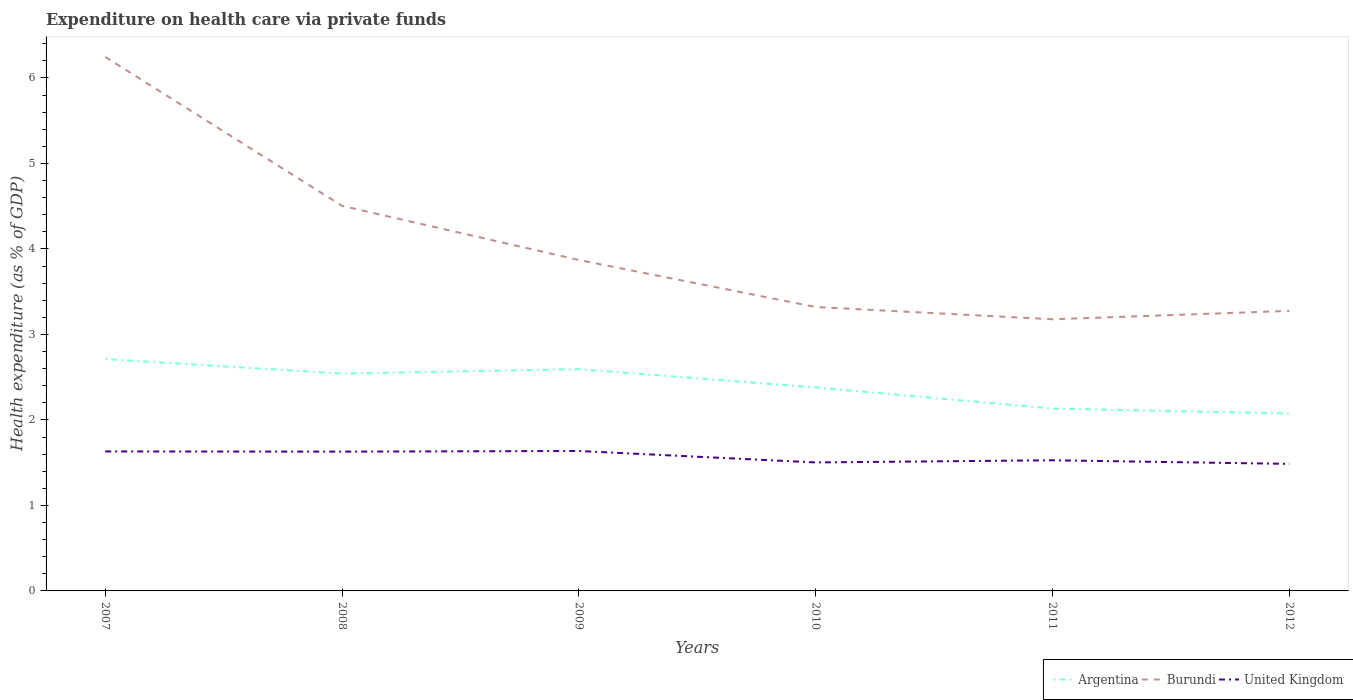How many different coloured lines are there?
Your answer should be very brief. 3. Is the number of lines equal to the number of legend labels?
Offer a terse response. Yes. Across all years, what is the maximum expenditure made on health care in United Kingdom?
Provide a succinct answer. 1.49. What is the total expenditure made on health care in Burundi in the graph?
Keep it short and to the point. 3.07. What is the difference between the highest and the second highest expenditure made on health care in Burundi?
Make the answer very short. 3.07. What is the difference between the highest and the lowest expenditure made on health care in Argentina?
Offer a terse response. 3. Is the expenditure made on health care in United Kingdom strictly greater than the expenditure made on health care in Argentina over the years?
Offer a terse response. Yes. How many lines are there?
Provide a short and direct response. 3. Does the graph contain any zero values?
Ensure brevity in your answer.  No. Does the graph contain grids?
Provide a short and direct response. No. Where does the legend appear in the graph?
Give a very brief answer. Bottom right. How many legend labels are there?
Keep it short and to the point. 3. How are the legend labels stacked?
Offer a very short reply. Horizontal. What is the title of the graph?
Ensure brevity in your answer.  Expenditure on health care via private funds. Does "Tanzania" appear as one of the legend labels in the graph?
Ensure brevity in your answer.  No. What is the label or title of the X-axis?
Give a very brief answer. Years. What is the label or title of the Y-axis?
Make the answer very short. Health expenditure (as % of GDP). What is the Health expenditure (as % of GDP) in Argentina in 2007?
Your answer should be compact. 2.71. What is the Health expenditure (as % of GDP) in Burundi in 2007?
Your answer should be very brief. 6.25. What is the Health expenditure (as % of GDP) of United Kingdom in 2007?
Give a very brief answer. 1.63. What is the Health expenditure (as % of GDP) of Argentina in 2008?
Ensure brevity in your answer.  2.54. What is the Health expenditure (as % of GDP) in Burundi in 2008?
Offer a very short reply. 4.5. What is the Health expenditure (as % of GDP) of United Kingdom in 2008?
Ensure brevity in your answer.  1.63. What is the Health expenditure (as % of GDP) in Argentina in 2009?
Your response must be concise. 2.59. What is the Health expenditure (as % of GDP) in Burundi in 2009?
Keep it short and to the point. 3.87. What is the Health expenditure (as % of GDP) of United Kingdom in 2009?
Provide a short and direct response. 1.64. What is the Health expenditure (as % of GDP) of Argentina in 2010?
Your response must be concise. 2.38. What is the Health expenditure (as % of GDP) of Burundi in 2010?
Your answer should be compact. 3.32. What is the Health expenditure (as % of GDP) in United Kingdom in 2010?
Offer a very short reply. 1.5. What is the Health expenditure (as % of GDP) in Argentina in 2011?
Offer a terse response. 2.13. What is the Health expenditure (as % of GDP) of Burundi in 2011?
Ensure brevity in your answer.  3.18. What is the Health expenditure (as % of GDP) in United Kingdom in 2011?
Offer a terse response. 1.53. What is the Health expenditure (as % of GDP) of Argentina in 2012?
Give a very brief answer. 2.08. What is the Health expenditure (as % of GDP) in Burundi in 2012?
Your answer should be very brief. 3.28. What is the Health expenditure (as % of GDP) in United Kingdom in 2012?
Offer a terse response. 1.49. Across all years, what is the maximum Health expenditure (as % of GDP) in Argentina?
Make the answer very short. 2.71. Across all years, what is the maximum Health expenditure (as % of GDP) of Burundi?
Provide a short and direct response. 6.25. Across all years, what is the maximum Health expenditure (as % of GDP) in United Kingdom?
Ensure brevity in your answer.  1.64. Across all years, what is the minimum Health expenditure (as % of GDP) in Argentina?
Offer a very short reply. 2.08. Across all years, what is the minimum Health expenditure (as % of GDP) in Burundi?
Your answer should be very brief. 3.18. Across all years, what is the minimum Health expenditure (as % of GDP) of United Kingdom?
Provide a short and direct response. 1.49. What is the total Health expenditure (as % of GDP) in Argentina in the graph?
Your answer should be compact. 14.44. What is the total Health expenditure (as % of GDP) of Burundi in the graph?
Make the answer very short. 24.4. What is the total Health expenditure (as % of GDP) of United Kingdom in the graph?
Give a very brief answer. 9.41. What is the difference between the Health expenditure (as % of GDP) of Argentina in 2007 and that in 2008?
Provide a succinct answer. 0.17. What is the difference between the Health expenditure (as % of GDP) in Burundi in 2007 and that in 2008?
Give a very brief answer. 1.74. What is the difference between the Health expenditure (as % of GDP) in United Kingdom in 2007 and that in 2008?
Offer a very short reply. 0. What is the difference between the Health expenditure (as % of GDP) in Argentina in 2007 and that in 2009?
Your answer should be very brief. 0.12. What is the difference between the Health expenditure (as % of GDP) of Burundi in 2007 and that in 2009?
Ensure brevity in your answer.  2.38. What is the difference between the Health expenditure (as % of GDP) of United Kingdom in 2007 and that in 2009?
Your response must be concise. -0.01. What is the difference between the Health expenditure (as % of GDP) in Argentina in 2007 and that in 2010?
Offer a very short reply. 0.33. What is the difference between the Health expenditure (as % of GDP) in Burundi in 2007 and that in 2010?
Make the answer very short. 2.93. What is the difference between the Health expenditure (as % of GDP) in United Kingdom in 2007 and that in 2010?
Make the answer very short. 0.13. What is the difference between the Health expenditure (as % of GDP) in Argentina in 2007 and that in 2011?
Your answer should be compact. 0.58. What is the difference between the Health expenditure (as % of GDP) in Burundi in 2007 and that in 2011?
Your answer should be compact. 3.07. What is the difference between the Health expenditure (as % of GDP) of United Kingdom in 2007 and that in 2011?
Provide a short and direct response. 0.1. What is the difference between the Health expenditure (as % of GDP) in Argentina in 2007 and that in 2012?
Give a very brief answer. 0.64. What is the difference between the Health expenditure (as % of GDP) of Burundi in 2007 and that in 2012?
Your answer should be very brief. 2.97. What is the difference between the Health expenditure (as % of GDP) in United Kingdom in 2007 and that in 2012?
Give a very brief answer. 0.15. What is the difference between the Health expenditure (as % of GDP) of Argentina in 2008 and that in 2009?
Keep it short and to the point. -0.05. What is the difference between the Health expenditure (as % of GDP) in Burundi in 2008 and that in 2009?
Give a very brief answer. 0.63. What is the difference between the Health expenditure (as % of GDP) in United Kingdom in 2008 and that in 2009?
Provide a succinct answer. -0.01. What is the difference between the Health expenditure (as % of GDP) in Argentina in 2008 and that in 2010?
Ensure brevity in your answer.  0.16. What is the difference between the Health expenditure (as % of GDP) of Burundi in 2008 and that in 2010?
Make the answer very short. 1.18. What is the difference between the Health expenditure (as % of GDP) in United Kingdom in 2008 and that in 2010?
Give a very brief answer. 0.13. What is the difference between the Health expenditure (as % of GDP) of Argentina in 2008 and that in 2011?
Your response must be concise. 0.41. What is the difference between the Health expenditure (as % of GDP) in Burundi in 2008 and that in 2011?
Provide a succinct answer. 1.33. What is the difference between the Health expenditure (as % of GDP) of United Kingdom in 2008 and that in 2011?
Your response must be concise. 0.1. What is the difference between the Health expenditure (as % of GDP) in Argentina in 2008 and that in 2012?
Offer a very short reply. 0.47. What is the difference between the Health expenditure (as % of GDP) of Burundi in 2008 and that in 2012?
Provide a short and direct response. 1.23. What is the difference between the Health expenditure (as % of GDP) in United Kingdom in 2008 and that in 2012?
Make the answer very short. 0.14. What is the difference between the Health expenditure (as % of GDP) in Argentina in 2009 and that in 2010?
Give a very brief answer. 0.21. What is the difference between the Health expenditure (as % of GDP) in Burundi in 2009 and that in 2010?
Offer a very short reply. 0.55. What is the difference between the Health expenditure (as % of GDP) of United Kingdom in 2009 and that in 2010?
Give a very brief answer. 0.13. What is the difference between the Health expenditure (as % of GDP) in Argentina in 2009 and that in 2011?
Ensure brevity in your answer.  0.46. What is the difference between the Health expenditure (as % of GDP) in Burundi in 2009 and that in 2011?
Offer a terse response. 0.69. What is the difference between the Health expenditure (as % of GDP) in United Kingdom in 2009 and that in 2011?
Give a very brief answer. 0.11. What is the difference between the Health expenditure (as % of GDP) in Argentina in 2009 and that in 2012?
Make the answer very short. 0.52. What is the difference between the Health expenditure (as % of GDP) of Burundi in 2009 and that in 2012?
Provide a succinct answer. 0.6. What is the difference between the Health expenditure (as % of GDP) of United Kingdom in 2009 and that in 2012?
Give a very brief answer. 0.15. What is the difference between the Health expenditure (as % of GDP) in Argentina in 2010 and that in 2011?
Provide a short and direct response. 0.25. What is the difference between the Health expenditure (as % of GDP) in Burundi in 2010 and that in 2011?
Provide a short and direct response. 0.14. What is the difference between the Health expenditure (as % of GDP) of United Kingdom in 2010 and that in 2011?
Your answer should be compact. -0.03. What is the difference between the Health expenditure (as % of GDP) of Argentina in 2010 and that in 2012?
Provide a short and direct response. 0.31. What is the difference between the Health expenditure (as % of GDP) in Burundi in 2010 and that in 2012?
Your answer should be compact. 0.05. What is the difference between the Health expenditure (as % of GDP) of United Kingdom in 2010 and that in 2012?
Make the answer very short. 0.02. What is the difference between the Health expenditure (as % of GDP) of Argentina in 2011 and that in 2012?
Provide a short and direct response. 0.06. What is the difference between the Health expenditure (as % of GDP) of Burundi in 2011 and that in 2012?
Your response must be concise. -0.1. What is the difference between the Health expenditure (as % of GDP) in United Kingdom in 2011 and that in 2012?
Keep it short and to the point. 0.04. What is the difference between the Health expenditure (as % of GDP) in Argentina in 2007 and the Health expenditure (as % of GDP) in Burundi in 2008?
Your answer should be very brief. -1.79. What is the difference between the Health expenditure (as % of GDP) of Argentina in 2007 and the Health expenditure (as % of GDP) of United Kingdom in 2008?
Ensure brevity in your answer.  1.08. What is the difference between the Health expenditure (as % of GDP) of Burundi in 2007 and the Health expenditure (as % of GDP) of United Kingdom in 2008?
Your response must be concise. 4.62. What is the difference between the Health expenditure (as % of GDP) in Argentina in 2007 and the Health expenditure (as % of GDP) in Burundi in 2009?
Provide a short and direct response. -1.16. What is the difference between the Health expenditure (as % of GDP) in Argentina in 2007 and the Health expenditure (as % of GDP) in United Kingdom in 2009?
Your response must be concise. 1.07. What is the difference between the Health expenditure (as % of GDP) in Burundi in 2007 and the Health expenditure (as % of GDP) in United Kingdom in 2009?
Your answer should be very brief. 4.61. What is the difference between the Health expenditure (as % of GDP) of Argentina in 2007 and the Health expenditure (as % of GDP) of Burundi in 2010?
Make the answer very short. -0.61. What is the difference between the Health expenditure (as % of GDP) in Argentina in 2007 and the Health expenditure (as % of GDP) in United Kingdom in 2010?
Provide a short and direct response. 1.21. What is the difference between the Health expenditure (as % of GDP) in Burundi in 2007 and the Health expenditure (as % of GDP) in United Kingdom in 2010?
Make the answer very short. 4.74. What is the difference between the Health expenditure (as % of GDP) of Argentina in 2007 and the Health expenditure (as % of GDP) of Burundi in 2011?
Provide a succinct answer. -0.47. What is the difference between the Health expenditure (as % of GDP) of Argentina in 2007 and the Health expenditure (as % of GDP) of United Kingdom in 2011?
Your answer should be compact. 1.18. What is the difference between the Health expenditure (as % of GDP) of Burundi in 2007 and the Health expenditure (as % of GDP) of United Kingdom in 2011?
Provide a succinct answer. 4.72. What is the difference between the Health expenditure (as % of GDP) of Argentina in 2007 and the Health expenditure (as % of GDP) of Burundi in 2012?
Your answer should be very brief. -0.56. What is the difference between the Health expenditure (as % of GDP) of Argentina in 2007 and the Health expenditure (as % of GDP) of United Kingdom in 2012?
Ensure brevity in your answer.  1.23. What is the difference between the Health expenditure (as % of GDP) of Burundi in 2007 and the Health expenditure (as % of GDP) of United Kingdom in 2012?
Your answer should be very brief. 4.76. What is the difference between the Health expenditure (as % of GDP) of Argentina in 2008 and the Health expenditure (as % of GDP) of Burundi in 2009?
Provide a short and direct response. -1.33. What is the difference between the Health expenditure (as % of GDP) of Argentina in 2008 and the Health expenditure (as % of GDP) of United Kingdom in 2009?
Make the answer very short. 0.91. What is the difference between the Health expenditure (as % of GDP) in Burundi in 2008 and the Health expenditure (as % of GDP) in United Kingdom in 2009?
Offer a terse response. 2.87. What is the difference between the Health expenditure (as % of GDP) of Argentina in 2008 and the Health expenditure (as % of GDP) of Burundi in 2010?
Your response must be concise. -0.78. What is the difference between the Health expenditure (as % of GDP) in Argentina in 2008 and the Health expenditure (as % of GDP) in United Kingdom in 2010?
Provide a short and direct response. 1.04. What is the difference between the Health expenditure (as % of GDP) of Burundi in 2008 and the Health expenditure (as % of GDP) of United Kingdom in 2010?
Provide a succinct answer. 3. What is the difference between the Health expenditure (as % of GDP) in Argentina in 2008 and the Health expenditure (as % of GDP) in Burundi in 2011?
Provide a succinct answer. -0.63. What is the difference between the Health expenditure (as % of GDP) in Argentina in 2008 and the Health expenditure (as % of GDP) in United Kingdom in 2011?
Your answer should be compact. 1.01. What is the difference between the Health expenditure (as % of GDP) of Burundi in 2008 and the Health expenditure (as % of GDP) of United Kingdom in 2011?
Ensure brevity in your answer.  2.98. What is the difference between the Health expenditure (as % of GDP) in Argentina in 2008 and the Health expenditure (as % of GDP) in Burundi in 2012?
Ensure brevity in your answer.  -0.73. What is the difference between the Health expenditure (as % of GDP) in Argentina in 2008 and the Health expenditure (as % of GDP) in United Kingdom in 2012?
Give a very brief answer. 1.06. What is the difference between the Health expenditure (as % of GDP) of Burundi in 2008 and the Health expenditure (as % of GDP) of United Kingdom in 2012?
Your answer should be compact. 3.02. What is the difference between the Health expenditure (as % of GDP) of Argentina in 2009 and the Health expenditure (as % of GDP) of Burundi in 2010?
Ensure brevity in your answer.  -0.73. What is the difference between the Health expenditure (as % of GDP) in Argentina in 2009 and the Health expenditure (as % of GDP) in United Kingdom in 2010?
Provide a succinct answer. 1.09. What is the difference between the Health expenditure (as % of GDP) of Burundi in 2009 and the Health expenditure (as % of GDP) of United Kingdom in 2010?
Your answer should be compact. 2.37. What is the difference between the Health expenditure (as % of GDP) in Argentina in 2009 and the Health expenditure (as % of GDP) in Burundi in 2011?
Keep it short and to the point. -0.58. What is the difference between the Health expenditure (as % of GDP) in Argentina in 2009 and the Health expenditure (as % of GDP) in United Kingdom in 2011?
Offer a terse response. 1.07. What is the difference between the Health expenditure (as % of GDP) of Burundi in 2009 and the Health expenditure (as % of GDP) of United Kingdom in 2011?
Ensure brevity in your answer.  2.34. What is the difference between the Health expenditure (as % of GDP) in Argentina in 2009 and the Health expenditure (as % of GDP) in Burundi in 2012?
Ensure brevity in your answer.  -0.68. What is the difference between the Health expenditure (as % of GDP) in Argentina in 2009 and the Health expenditure (as % of GDP) in United Kingdom in 2012?
Offer a very short reply. 1.11. What is the difference between the Health expenditure (as % of GDP) of Burundi in 2009 and the Health expenditure (as % of GDP) of United Kingdom in 2012?
Ensure brevity in your answer.  2.39. What is the difference between the Health expenditure (as % of GDP) in Argentina in 2010 and the Health expenditure (as % of GDP) in Burundi in 2011?
Your answer should be compact. -0.8. What is the difference between the Health expenditure (as % of GDP) of Argentina in 2010 and the Health expenditure (as % of GDP) of United Kingdom in 2011?
Your answer should be compact. 0.85. What is the difference between the Health expenditure (as % of GDP) in Burundi in 2010 and the Health expenditure (as % of GDP) in United Kingdom in 2011?
Provide a short and direct response. 1.79. What is the difference between the Health expenditure (as % of GDP) of Argentina in 2010 and the Health expenditure (as % of GDP) of Burundi in 2012?
Give a very brief answer. -0.9. What is the difference between the Health expenditure (as % of GDP) of Argentina in 2010 and the Health expenditure (as % of GDP) of United Kingdom in 2012?
Your answer should be very brief. 0.89. What is the difference between the Health expenditure (as % of GDP) in Burundi in 2010 and the Health expenditure (as % of GDP) in United Kingdom in 2012?
Keep it short and to the point. 1.83. What is the difference between the Health expenditure (as % of GDP) of Argentina in 2011 and the Health expenditure (as % of GDP) of Burundi in 2012?
Your answer should be compact. -1.14. What is the difference between the Health expenditure (as % of GDP) in Argentina in 2011 and the Health expenditure (as % of GDP) in United Kingdom in 2012?
Your answer should be very brief. 0.65. What is the difference between the Health expenditure (as % of GDP) of Burundi in 2011 and the Health expenditure (as % of GDP) of United Kingdom in 2012?
Your answer should be compact. 1.69. What is the average Health expenditure (as % of GDP) in Argentina per year?
Provide a succinct answer. 2.41. What is the average Health expenditure (as % of GDP) in Burundi per year?
Your response must be concise. 4.07. What is the average Health expenditure (as % of GDP) in United Kingdom per year?
Ensure brevity in your answer.  1.57. In the year 2007, what is the difference between the Health expenditure (as % of GDP) of Argentina and Health expenditure (as % of GDP) of Burundi?
Give a very brief answer. -3.53. In the year 2007, what is the difference between the Health expenditure (as % of GDP) in Argentina and Health expenditure (as % of GDP) in United Kingdom?
Offer a very short reply. 1.08. In the year 2007, what is the difference between the Health expenditure (as % of GDP) in Burundi and Health expenditure (as % of GDP) in United Kingdom?
Make the answer very short. 4.61. In the year 2008, what is the difference between the Health expenditure (as % of GDP) in Argentina and Health expenditure (as % of GDP) in Burundi?
Keep it short and to the point. -1.96. In the year 2008, what is the difference between the Health expenditure (as % of GDP) of Argentina and Health expenditure (as % of GDP) of United Kingdom?
Your answer should be compact. 0.91. In the year 2008, what is the difference between the Health expenditure (as % of GDP) of Burundi and Health expenditure (as % of GDP) of United Kingdom?
Your answer should be very brief. 2.87. In the year 2009, what is the difference between the Health expenditure (as % of GDP) of Argentina and Health expenditure (as % of GDP) of Burundi?
Your answer should be very brief. -1.28. In the year 2009, what is the difference between the Health expenditure (as % of GDP) of Argentina and Health expenditure (as % of GDP) of United Kingdom?
Keep it short and to the point. 0.96. In the year 2009, what is the difference between the Health expenditure (as % of GDP) of Burundi and Health expenditure (as % of GDP) of United Kingdom?
Give a very brief answer. 2.23. In the year 2010, what is the difference between the Health expenditure (as % of GDP) in Argentina and Health expenditure (as % of GDP) in Burundi?
Provide a short and direct response. -0.94. In the year 2010, what is the difference between the Health expenditure (as % of GDP) in Argentina and Health expenditure (as % of GDP) in United Kingdom?
Provide a succinct answer. 0.88. In the year 2010, what is the difference between the Health expenditure (as % of GDP) of Burundi and Health expenditure (as % of GDP) of United Kingdom?
Provide a succinct answer. 1.82. In the year 2011, what is the difference between the Health expenditure (as % of GDP) of Argentina and Health expenditure (as % of GDP) of Burundi?
Offer a very short reply. -1.04. In the year 2011, what is the difference between the Health expenditure (as % of GDP) of Argentina and Health expenditure (as % of GDP) of United Kingdom?
Keep it short and to the point. 0.6. In the year 2011, what is the difference between the Health expenditure (as % of GDP) in Burundi and Health expenditure (as % of GDP) in United Kingdom?
Your answer should be compact. 1.65. In the year 2012, what is the difference between the Health expenditure (as % of GDP) of Argentina and Health expenditure (as % of GDP) of Burundi?
Offer a terse response. -1.2. In the year 2012, what is the difference between the Health expenditure (as % of GDP) in Argentina and Health expenditure (as % of GDP) in United Kingdom?
Offer a very short reply. 0.59. In the year 2012, what is the difference between the Health expenditure (as % of GDP) of Burundi and Health expenditure (as % of GDP) of United Kingdom?
Your answer should be very brief. 1.79. What is the ratio of the Health expenditure (as % of GDP) in Argentina in 2007 to that in 2008?
Your response must be concise. 1.07. What is the ratio of the Health expenditure (as % of GDP) of Burundi in 2007 to that in 2008?
Offer a very short reply. 1.39. What is the ratio of the Health expenditure (as % of GDP) in United Kingdom in 2007 to that in 2008?
Your response must be concise. 1. What is the ratio of the Health expenditure (as % of GDP) in Argentina in 2007 to that in 2009?
Provide a succinct answer. 1.05. What is the ratio of the Health expenditure (as % of GDP) of Burundi in 2007 to that in 2009?
Your answer should be compact. 1.61. What is the ratio of the Health expenditure (as % of GDP) in Argentina in 2007 to that in 2010?
Keep it short and to the point. 1.14. What is the ratio of the Health expenditure (as % of GDP) of Burundi in 2007 to that in 2010?
Ensure brevity in your answer.  1.88. What is the ratio of the Health expenditure (as % of GDP) of United Kingdom in 2007 to that in 2010?
Your answer should be very brief. 1.09. What is the ratio of the Health expenditure (as % of GDP) of Argentina in 2007 to that in 2011?
Provide a succinct answer. 1.27. What is the ratio of the Health expenditure (as % of GDP) of Burundi in 2007 to that in 2011?
Make the answer very short. 1.97. What is the ratio of the Health expenditure (as % of GDP) of United Kingdom in 2007 to that in 2011?
Provide a short and direct response. 1.07. What is the ratio of the Health expenditure (as % of GDP) of Argentina in 2007 to that in 2012?
Your answer should be very brief. 1.31. What is the ratio of the Health expenditure (as % of GDP) in Burundi in 2007 to that in 2012?
Ensure brevity in your answer.  1.91. What is the ratio of the Health expenditure (as % of GDP) of United Kingdom in 2007 to that in 2012?
Keep it short and to the point. 1.1. What is the ratio of the Health expenditure (as % of GDP) of Argentina in 2008 to that in 2009?
Ensure brevity in your answer.  0.98. What is the ratio of the Health expenditure (as % of GDP) of Burundi in 2008 to that in 2009?
Your answer should be compact. 1.16. What is the ratio of the Health expenditure (as % of GDP) in United Kingdom in 2008 to that in 2009?
Provide a short and direct response. 1. What is the ratio of the Health expenditure (as % of GDP) in Argentina in 2008 to that in 2010?
Offer a terse response. 1.07. What is the ratio of the Health expenditure (as % of GDP) of Burundi in 2008 to that in 2010?
Ensure brevity in your answer.  1.36. What is the ratio of the Health expenditure (as % of GDP) of United Kingdom in 2008 to that in 2010?
Your answer should be very brief. 1.08. What is the ratio of the Health expenditure (as % of GDP) in Argentina in 2008 to that in 2011?
Ensure brevity in your answer.  1.19. What is the ratio of the Health expenditure (as % of GDP) of Burundi in 2008 to that in 2011?
Offer a terse response. 1.42. What is the ratio of the Health expenditure (as % of GDP) of United Kingdom in 2008 to that in 2011?
Provide a succinct answer. 1.07. What is the ratio of the Health expenditure (as % of GDP) of Argentina in 2008 to that in 2012?
Keep it short and to the point. 1.23. What is the ratio of the Health expenditure (as % of GDP) of Burundi in 2008 to that in 2012?
Offer a very short reply. 1.38. What is the ratio of the Health expenditure (as % of GDP) of United Kingdom in 2008 to that in 2012?
Ensure brevity in your answer.  1.1. What is the ratio of the Health expenditure (as % of GDP) of Argentina in 2009 to that in 2010?
Your answer should be compact. 1.09. What is the ratio of the Health expenditure (as % of GDP) of Burundi in 2009 to that in 2010?
Make the answer very short. 1.17. What is the ratio of the Health expenditure (as % of GDP) of United Kingdom in 2009 to that in 2010?
Make the answer very short. 1.09. What is the ratio of the Health expenditure (as % of GDP) in Argentina in 2009 to that in 2011?
Keep it short and to the point. 1.22. What is the ratio of the Health expenditure (as % of GDP) in Burundi in 2009 to that in 2011?
Offer a terse response. 1.22. What is the ratio of the Health expenditure (as % of GDP) of United Kingdom in 2009 to that in 2011?
Ensure brevity in your answer.  1.07. What is the ratio of the Health expenditure (as % of GDP) of Argentina in 2009 to that in 2012?
Offer a very short reply. 1.25. What is the ratio of the Health expenditure (as % of GDP) of Burundi in 2009 to that in 2012?
Your answer should be very brief. 1.18. What is the ratio of the Health expenditure (as % of GDP) in United Kingdom in 2009 to that in 2012?
Provide a short and direct response. 1.1. What is the ratio of the Health expenditure (as % of GDP) in Argentina in 2010 to that in 2011?
Your answer should be compact. 1.12. What is the ratio of the Health expenditure (as % of GDP) of Burundi in 2010 to that in 2011?
Your answer should be compact. 1.05. What is the ratio of the Health expenditure (as % of GDP) in United Kingdom in 2010 to that in 2011?
Offer a terse response. 0.98. What is the ratio of the Health expenditure (as % of GDP) in Argentina in 2010 to that in 2012?
Give a very brief answer. 1.15. What is the ratio of the Health expenditure (as % of GDP) in Burundi in 2010 to that in 2012?
Your answer should be compact. 1.01. What is the ratio of the Health expenditure (as % of GDP) in United Kingdom in 2010 to that in 2012?
Offer a very short reply. 1.01. What is the ratio of the Health expenditure (as % of GDP) in Argentina in 2011 to that in 2012?
Ensure brevity in your answer.  1.03. What is the ratio of the Health expenditure (as % of GDP) in Burundi in 2011 to that in 2012?
Ensure brevity in your answer.  0.97. What is the ratio of the Health expenditure (as % of GDP) in United Kingdom in 2011 to that in 2012?
Your answer should be very brief. 1.03. What is the difference between the highest and the second highest Health expenditure (as % of GDP) in Argentina?
Provide a succinct answer. 0.12. What is the difference between the highest and the second highest Health expenditure (as % of GDP) of Burundi?
Provide a succinct answer. 1.74. What is the difference between the highest and the second highest Health expenditure (as % of GDP) in United Kingdom?
Your answer should be compact. 0.01. What is the difference between the highest and the lowest Health expenditure (as % of GDP) of Argentina?
Give a very brief answer. 0.64. What is the difference between the highest and the lowest Health expenditure (as % of GDP) in Burundi?
Keep it short and to the point. 3.07. What is the difference between the highest and the lowest Health expenditure (as % of GDP) of United Kingdom?
Ensure brevity in your answer.  0.15. 